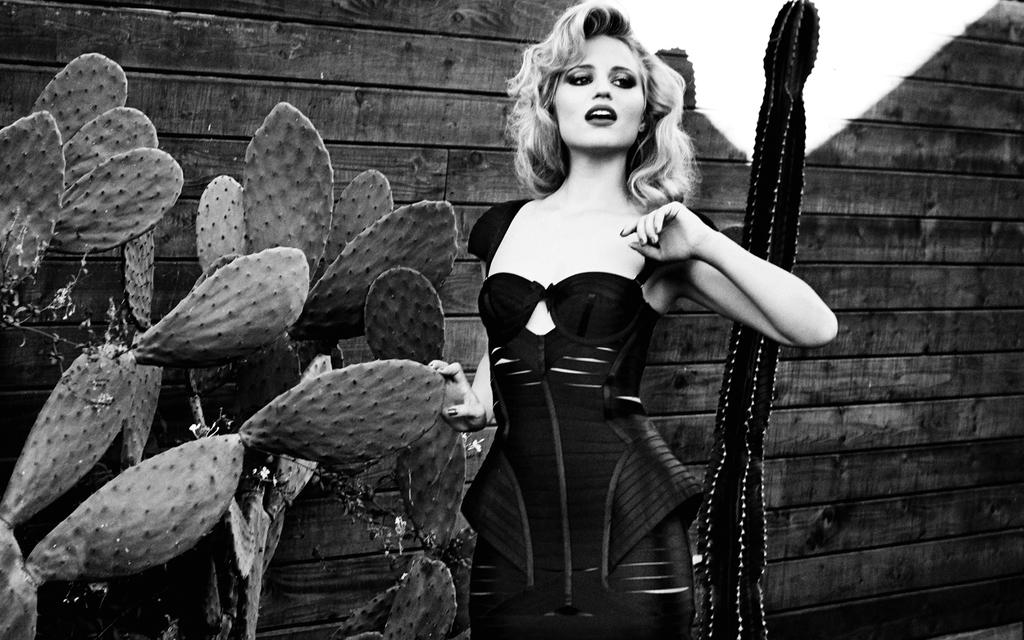Who is the main subject in the image? There is a lady standing in the center of the image. What type of plants can be seen in the image? There are cactus plants in the image. What is the background of the image made of? There is a wooden wall in the background of the image. What color is the paint on the lady's face in the image? There is no paint on the lady's face in the image; she appears to have no makeup or paint. 